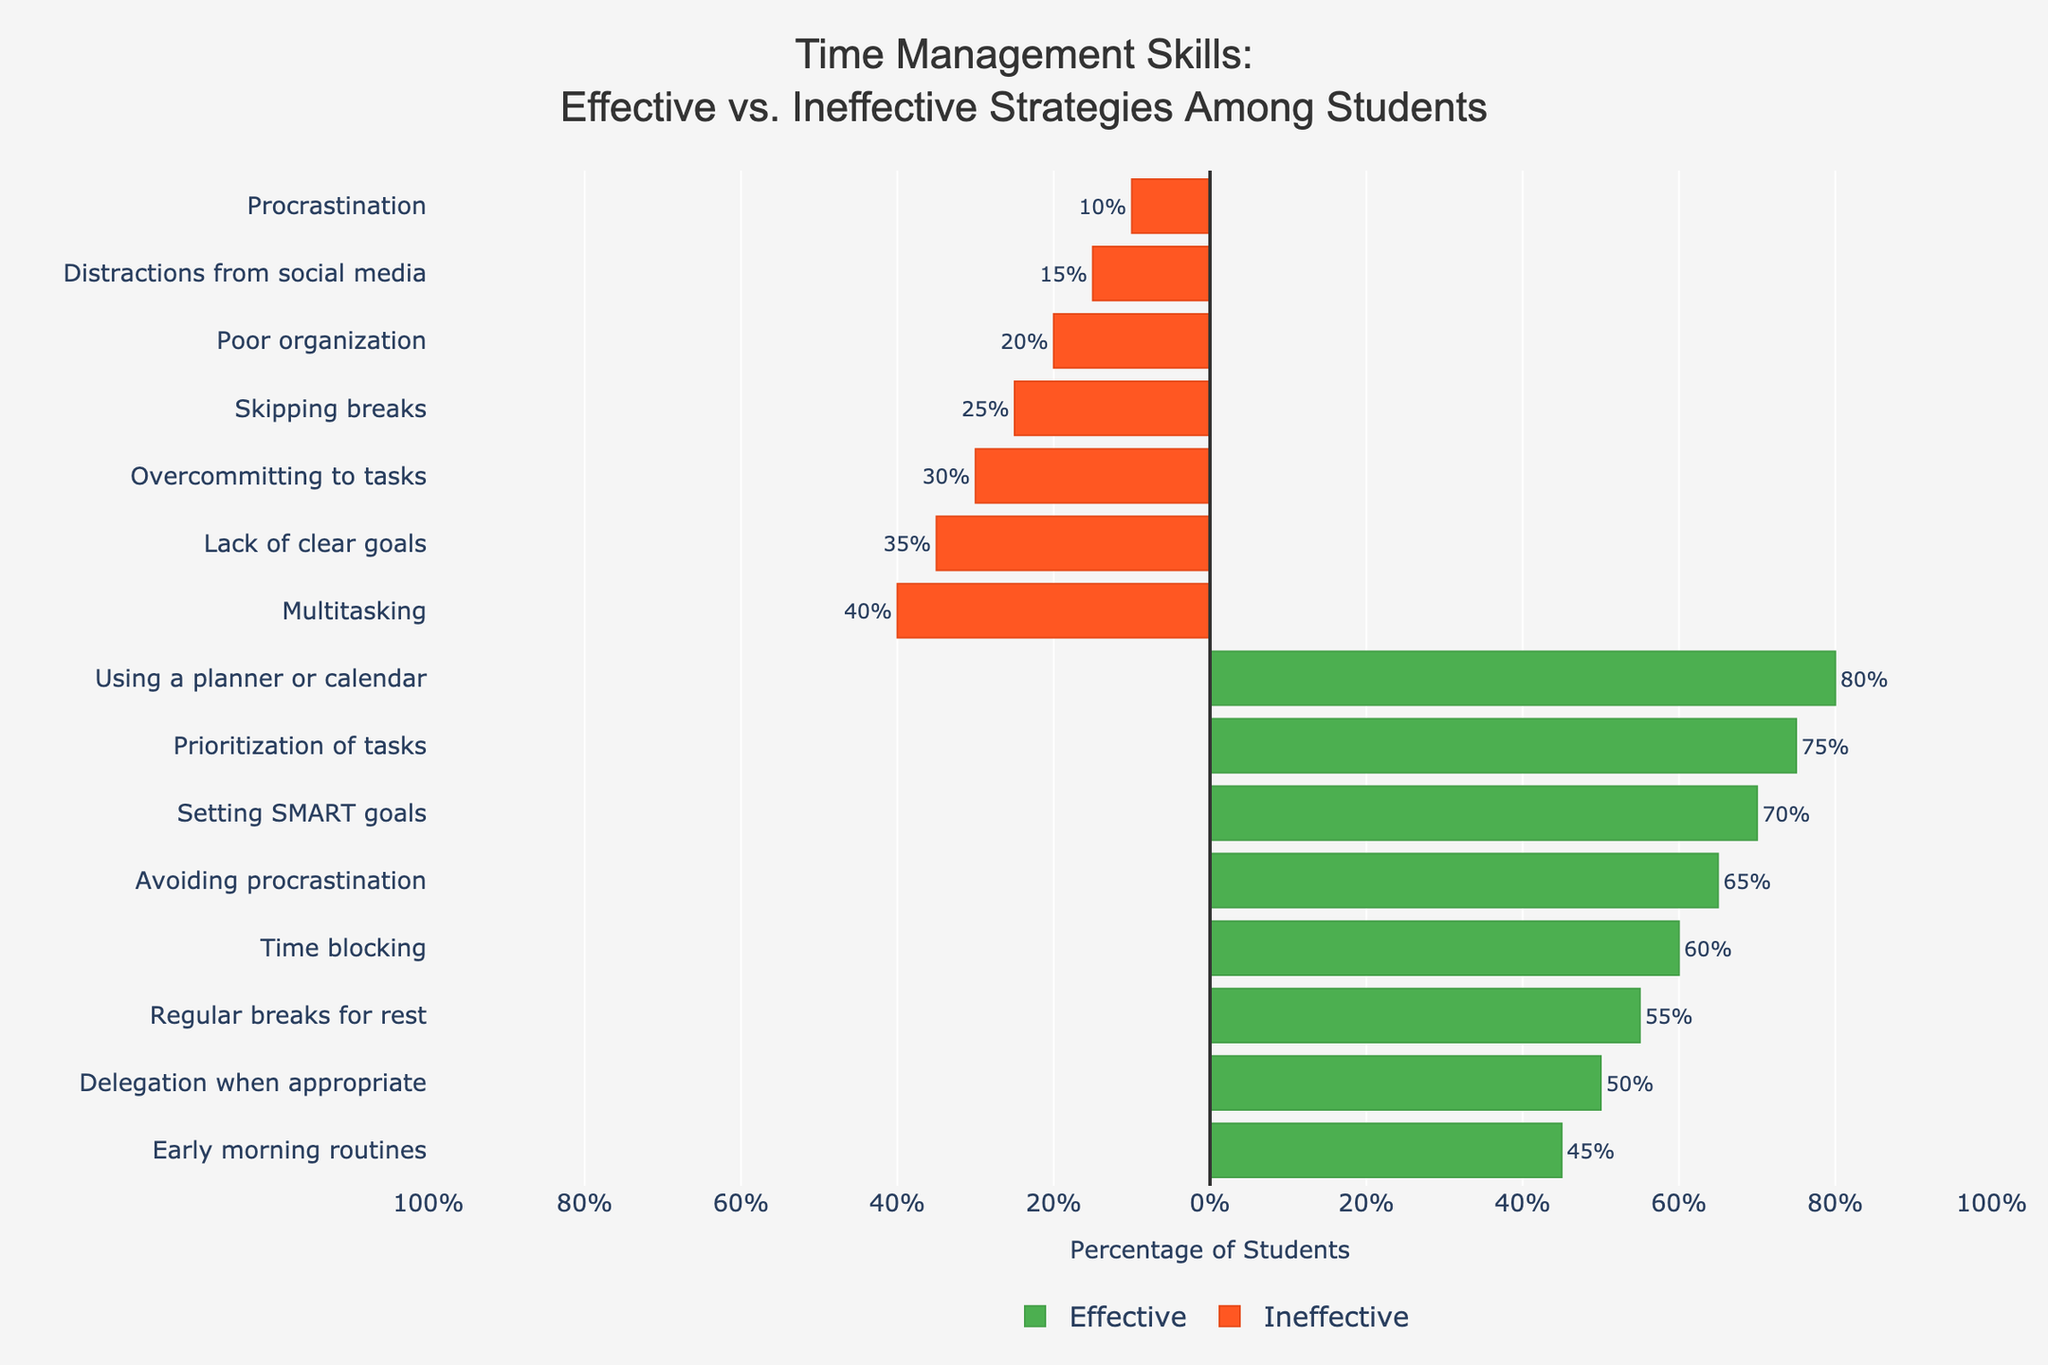Which effective strategy has the highest percentage of students using it? Look at the green bars (representing effective strategies) and identify the highest one. The bar for "Using a planner or calendar" is the longest.
Answer: Using a planner or calendar Which ineffective strategy has the lowest percentage of students using it? Look at the red bars (representing ineffective strategies) and identify the shortest one. The bar for "Procrastination" is the shortest.
Answer: Procrastination What is the difference in percentage between students using "Prioritization of tasks" and those with "Distractions from social media"? Find the percentage for "Prioritization of tasks" and "Distractions from social media". The values are 75% and 15%, respectively. Subtract 15% from 75% to get the difference. 75% - 15% = 60%
Answer: 60% What is the sum of the percentages of the top two effective strategies? The top two effective strategies are "Using a planner or calendar" (80%) and "Prioritization of tasks" (75%). Add these percentages together. 80% + 75% = 155%
Answer: 155% How does the percentage of students who "Avoid procrastination" compare to those who "Procrastinate"? Identify the percentages for "Avoiding procrastination" (65%) and "Procrastination" (10%). Compare the two values: 65% is much higher than 10%.
Answer: Higher Which strategies have more students using them: effective or ineffective ones? Add up the percentages for all effective and ineffective strategies separately. Effective: 75 + 70 + 65 + 80 + 60 + 55 + 50 + 45 = 500%. Ineffective: 40 + 35 + 30 + 25 + 20 + 15 + 10 = 175%. Compare the totals.
Answer: Effective How many ineffective strategies have a lower percentage than the lowest effective strategy? The lowest effective strategy is "Early morning routines" at 45%. Count the ineffective strategies with percentages less than 45%: there are 5 (35%, 30%, 25%, 20%, 15%, and 10%).
Answer: 6 What is the median percentage of students using ineffective strategies? List the percentages of ineffective strategies in ascending order: 10%, 15%, 20%, 25%, 30%, 35%, 40%. The median value is the middle one, which is 25%.
Answer: 25% What percentage of students set SMART goals? Look at the green bars for effective strategies. The percentage for "Setting SMART goals" is 70%.
Answer: 70% Is "Overcommitting to tasks" more or less common than "Skipping breaks"? Reference the red bars for ineffective strategies. "Overcommitting to tasks" has a percentage of 30%, while "Skipping breaks" has 25%. "Overcommitting to tasks" is more common.
Answer: More common 